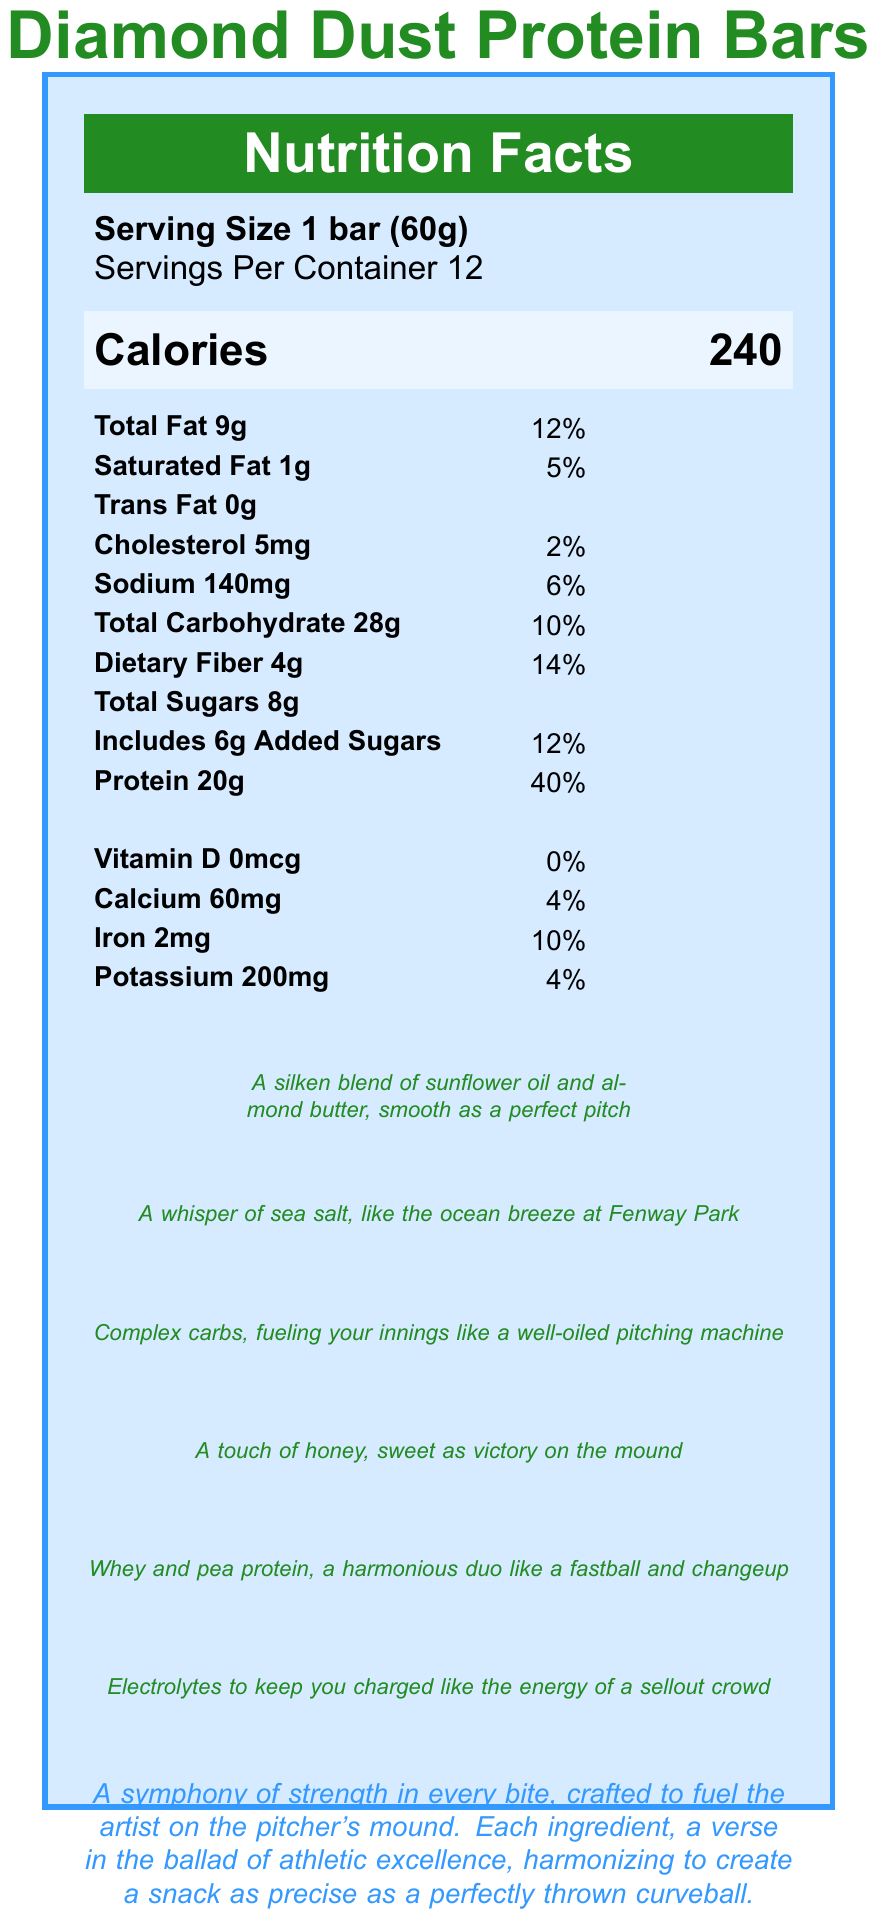what is the serving size of Diamond Dust Protein Bars? The serving size for Diamond Dust Protein Bars is explicitly stated as 1 bar (60g).
Answer: 1 bar (60g) how many calories are in one serving? The calories per serving are listed as 240.
Answer: 240 how many grams of total fat are in a serving? The total fat content per serving is specified as 9g.
Answer: 9g what percentage of the daily value of protein does one bar provide? The nutrition facts indicate that one bar provides 40% of the daily value for protein.
Answer: 40% describe the poetic nature of the sodium content. The document gives a poetic description of the sodium as "A whisper of sea salt, like the ocean breeze at Fenway Park."
Answer: A whisper of sea salt, like the ocean breeze at Fenway Park how many grams of added sugars are in a serving? The added sugars per serving are listed as 6g.
Answer: 6g what is the source of the protein in the bar? A. Whey protein isolate and milk protein B. Pea protein and soy protein C. Whey protein isolate and pea protein D. Soy protein and milk protein The document specifies that the protein sources are whey protein isolate and pea protein.
Answer: C how much dietary fiber is present in a single bar? The dietary fiber content per serving is listed as 4g.
Answer: 4g what is the amount of calcium per serving? A. 10mg B. 60mg C. 120mg D. 200mg The amount of calcium per serving is 60mg.
Answer: B is there any trans fat in a serving of Diamond Dust Protein Bars? The document states that there is 0g of trans fat in a serving.
Answer: No what is the poetic description of the total carbohydrate content? The poetic description for total carbohydrates is "Complex carbs, fueling your innings like a well-oiled pitching machine."
Answer: Complex carbs, fueling your innings like a well-oiled pitching machine how many ingredients are listed for the bar? The document lists 9 ingredients: Whey protein isolate, Pea protein, Rolled oats, Almond butter, Honey, Dried cranberries, Sunflower oil, Sea salt, and Natural flavors.
Answer: 9 what vitamin has a 0% daily value in the bar? The document specifies that the bars contain 0% of the daily value for Vitamin D.
Answer: Vitamin D what minerals are present in the bar and what are their respective daily values? The minerals listed in the document are Calcium (4% daily value), Iron (10% daily value), and Potassium (4% daily value).
Answer: Calcium 4%, Iron 10%, Potassium 4% describe the overall theme of the nutrition facts label document. The document presents a poetic and artistic description of Diamond Dust Protein Bars, emphasizing their nutritional benefits and equating their quality to the precise and skillful nature of a pitcher's performance on the mound.
Answer: A symphony of strength in every bite, crafted to fuel the artist on the pitcher's mound. Each ingredient, a verse in the ballad of athletic excellence, harmonizing to create a snack as precise as a perfectly thrown curveball. how much sodium does one bar contain? The sodium content per serving is 140mg.
Answer: 140mg what are the added sugars described as? The added sugars are described poetically as "A touch of honey, sweet as victory on the mound."
Answer: A touch of honey, sweet as victory on the mound does the document provide information on the total price of a container of bars? The nutrition facts label does not include any pricing information.
Answer: Cannot be determined 